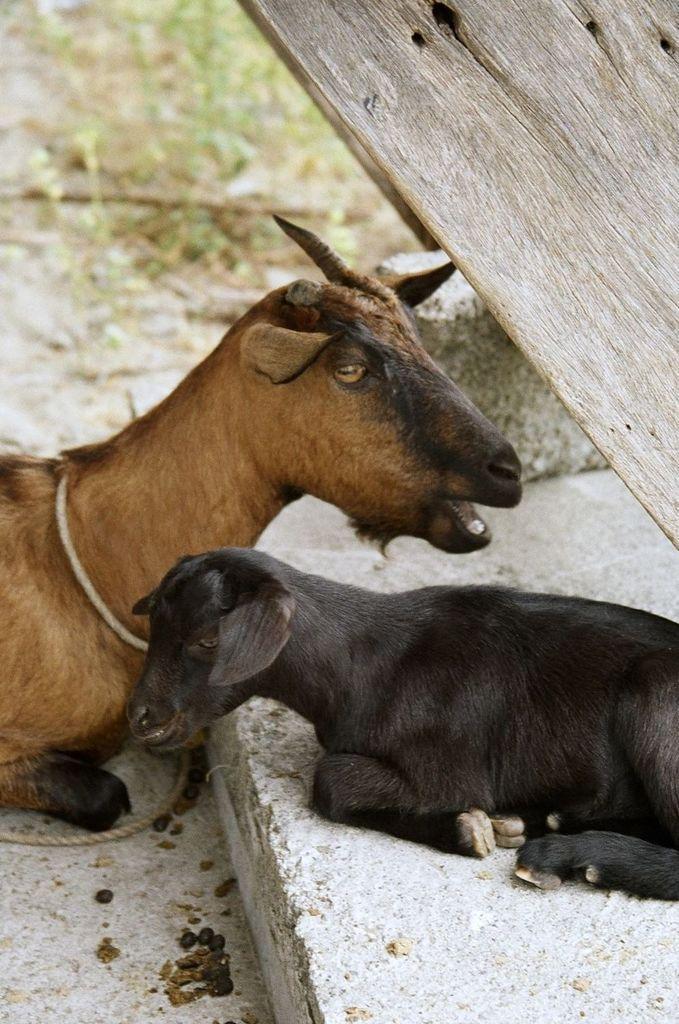Could you give a brief overview of what you see in this image? In this image, I can see a goat and a lamb are sitting. This looks like a wooden board. The background looks blurry. I think this is the rock. 